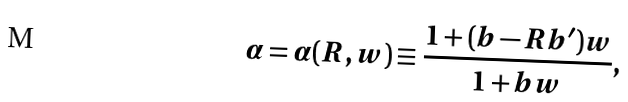Convert formula to latex. <formula><loc_0><loc_0><loc_500><loc_500>\alpha = \alpha ( R , w ) \equiv \frac { 1 + ( b - R b ^ { \prime } ) w } { 1 + b w } ,</formula> 